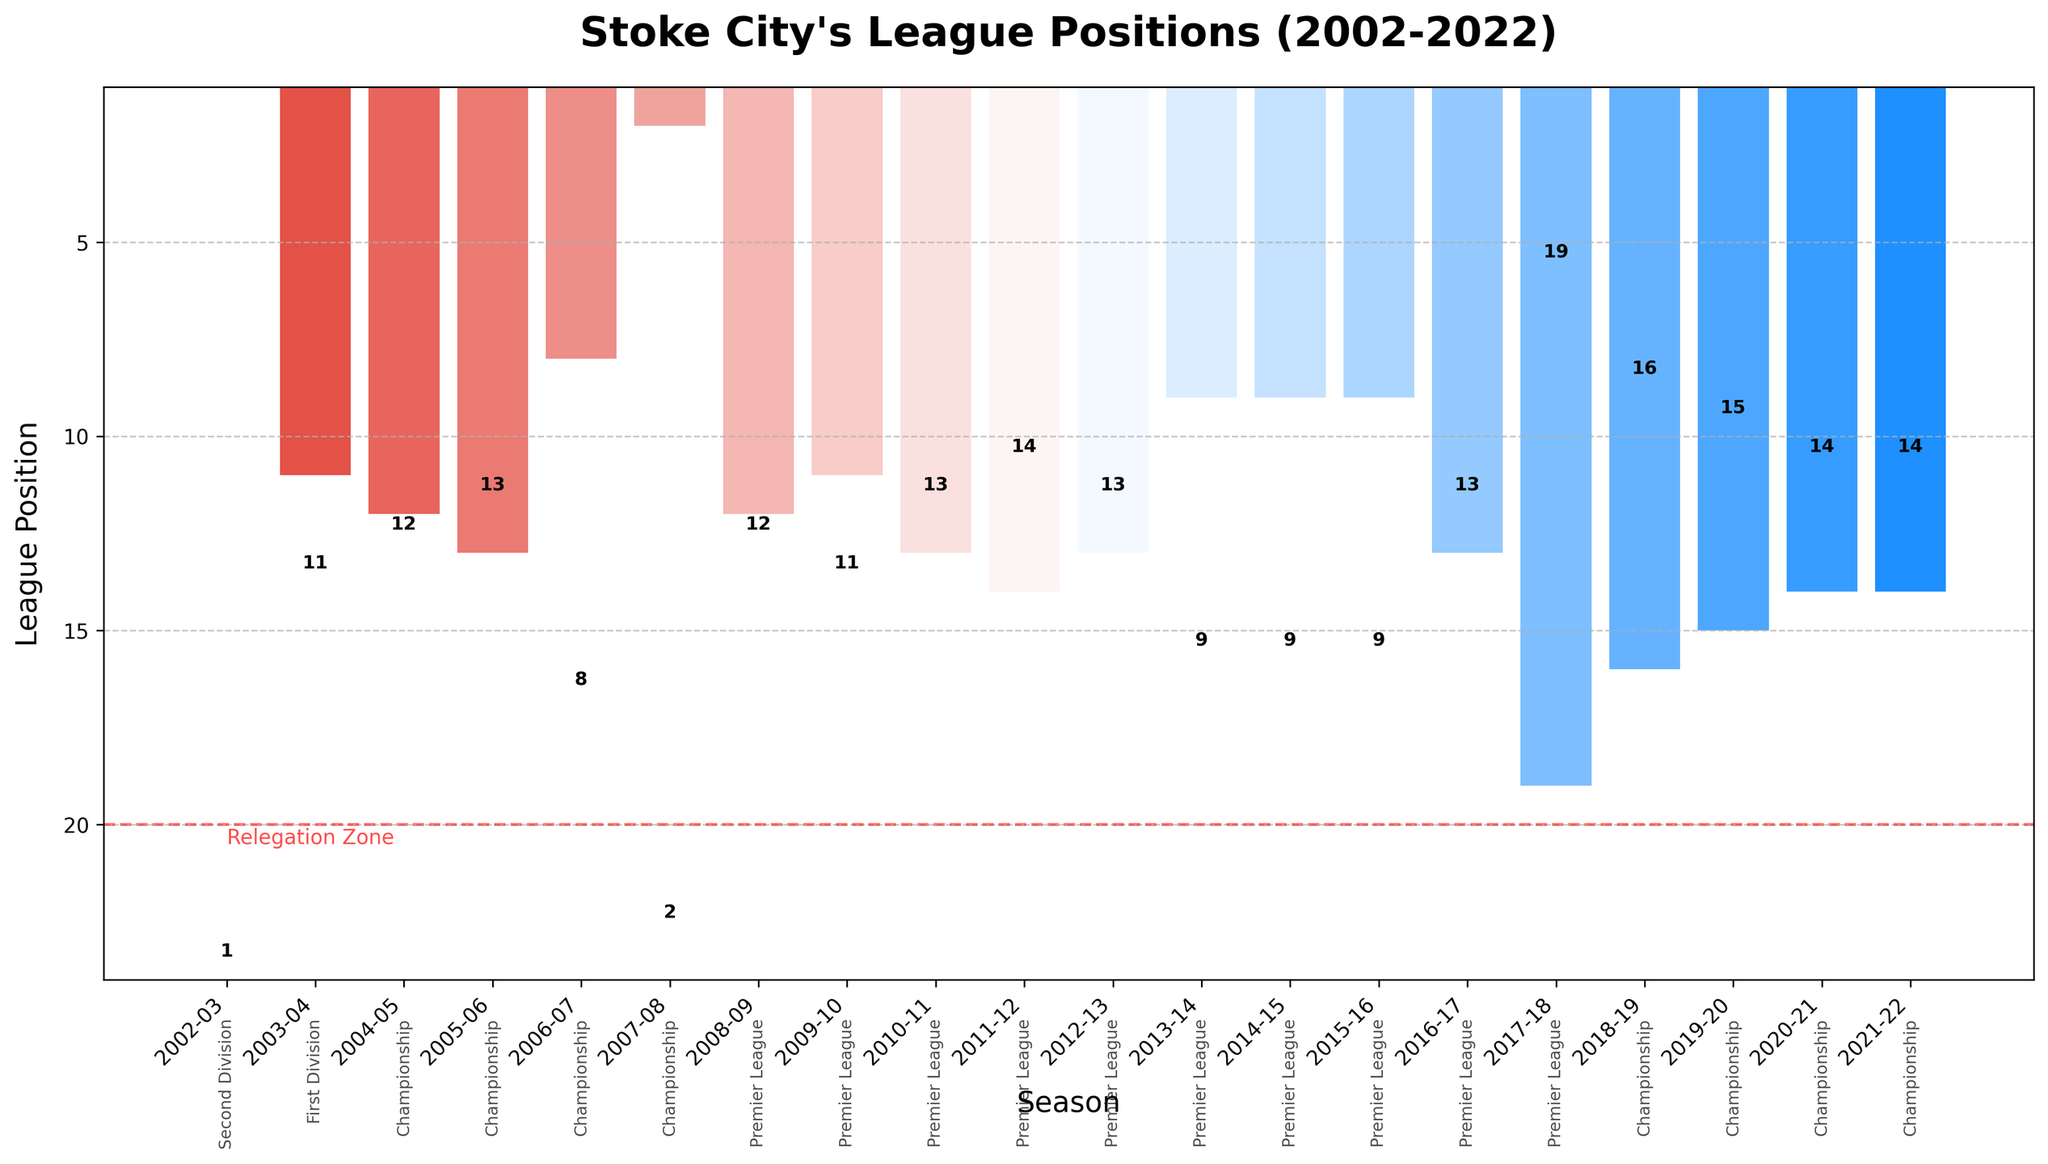Which season shows the highest league position Stoke City achieved? The highest league position is represented by the bar with the lowest value in height, which occurs in the 2002-03 season in the Second Division.
Answer: 2002-03 In which season did Stoke City finish 19th in the Premier League? The bar corresponding to the Premier League season with a height value of 19 can be observed in the 2017-18 season.
Answer: 2017-18 What's the difference in league positions between 2008-09 and 2016-17? The 2008-09 season has a league position of 12, and the 2016-17 season has a league position of 13. The difference is 13 - 12 = 1.
Answer: 1 How many times did Stoke City finish in the top 10 of the Premier League? Count the bars labeled "Premier League" and check if their height values are in the range 1 to 10. The seasons are 2013-14, 2014-15, and 2015-16. Thus, 3 times.
Answer: 3 Which division did Stoke City play in during the 2005-06 season, and what was their league position? The bar for the 2005-06 season is labeled "Championship," with a league position of 13, shown in the bar height.
Answer: Championship, 13 In which season and division did Stoke City's league position drop to the 16th? The bar corresponding to the 16th position is in the 2018-19 season in the Championship division.
Answer: 2018-19, Championship What was the trend in Stoke City's league positions in the Premier League from the 2013-14 to 2016-17 seasons? Starting with 9th in the 2013-14 season, Stoke City maintained a 9th place through the 2014-15 and 2015-16 seasons and then dropped to 13th place in the 2016-17 season.
Answer: Decreasing Identify the season with the best league position in the Championship and state that position. The shortest bar for Championship seasons, indicating the best position, is in the 2007-08 season with a league position of 2.
Answer: 2007-08, 2 Did Stoke City ever finish between 10th and 15th in the Premier League? If so, list the seasons. Yes, by reviewing the Premier League bars with heights between 10 and 15: the seasons are 2008-09, 2009-10, 2010-11, 2011-12, 2012-13, and 2016-17.
Answer: 2008-09, 2009-10, 2010-11, 2011-12, 2012-13, 2016-17 